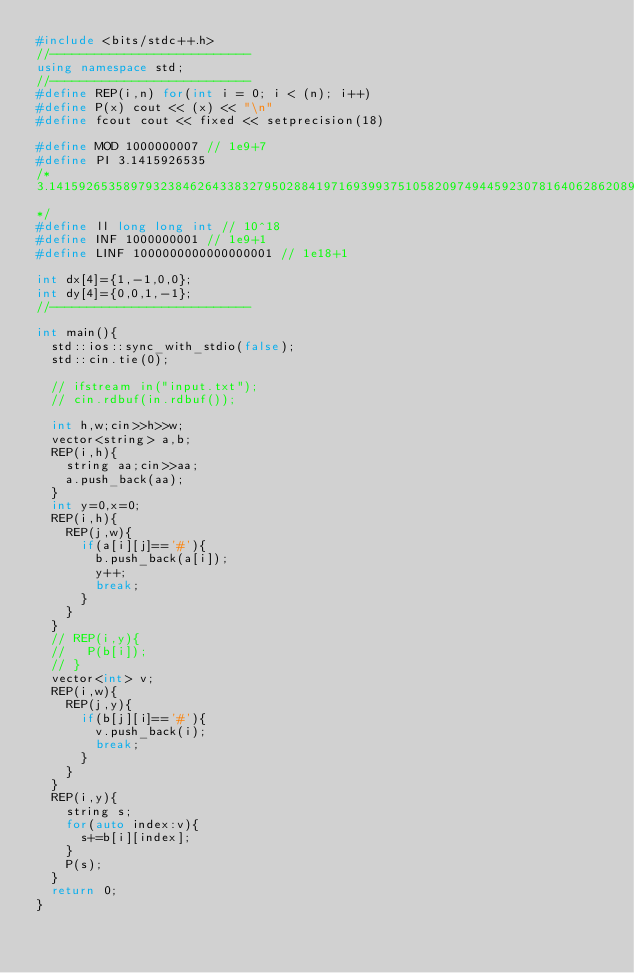<code> <loc_0><loc_0><loc_500><loc_500><_C++_>#include <bits/stdc++.h>
//---------------------------
using namespace std;
//---------------------------
#define REP(i,n) for(int i = 0; i < (n); i++)
#define P(x) cout << (x) << "\n"
#define fcout cout << fixed << setprecision(18)

#define MOD 1000000007 // 1e9+7
#define PI 3.1415926535
/*
3.1415926535897932384626433832795028841971693993751058209749445923078164062862089986280348253421170679
*/
#define ll long long int // 10^18
#define INF 1000000001 // 1e9+1
#define LINF 1000000000000000001 // 1e18+1

int dx[4]={1,-1,0,0};
int dy[4]={0,0,1,-1};
//---------------------------

int main(){
  std::ios::sync_with_stdio(false);
  std::cin.tie(0);

  // ifstream in("input.txt");
  // cin.rdbuf(in.rdbuf());

  int h,w;cin>>h>>w;
  vector<string> a,b;
  REP(i,h){
    string aa;cin>>aa;
    a.push_back(aa);
  }
  int y=0,x=0;
  REP(i,h){
    REP(j,w){
      if(a[i][j]=='#'){
        b.push_back(a[i]);
        y++;
        break;
      }
    }
  }
  // REP(i,y){
  //   P(b[i]);
  // }
  vector<int> v;
  REP(i,w){
    REP(j,y){
      if(b[j][i]=='#'){
        v.push_back(i);
        break;
      }
    }
  }
  REP(i,y){
    string s;
    for(auto index:v){
      s+=b[i][index];
    }
    P(s);
  }
  return 0;
}
</code> 